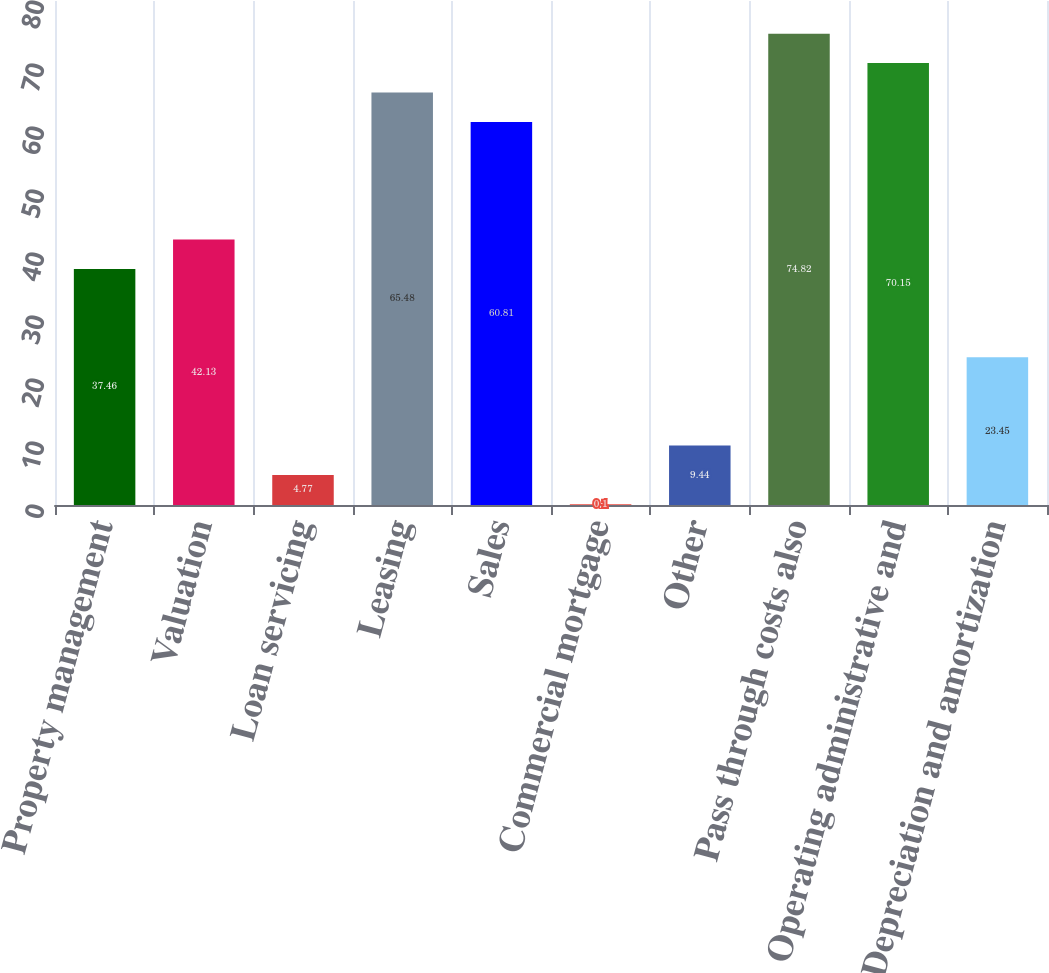<chart> <loc_0><loc_0><loc_500><loc_500><bar_chart><fcel>Property management<fcel>Valuation<fcel>Loan servicing<fcel>Leasing<fcel>Sales<fcel>Commercial mortgage<fcel>Other<fcel>Pass through costs also<fcel>Operating administrative and<fcel>Depreciation and amortization<nl><fcel>37.46<fcel>42.13<fcel>4.77<fcel>65.48<fcel>60.81<fcel>0.1<fcel>9.44<fcel>74.82<fcel>70.15<fcel>23.45<nl></chart> 